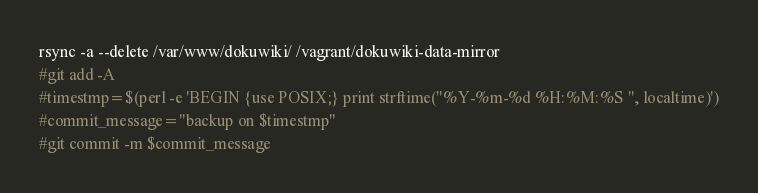Convert code to text. <code><loc_0><loc_0><loc_500><loc_500><_Bash_>rsync -a --delete /var/www/dokuwiki/ /vagrant/dokuwiki-data-mirror
#git add -A
#timestmp=$(perl -e 'BEGIN {use POSIX;} print strftime("%Y-%m-%d %H:%M:%S ", localtime)')
#commit_message="backup on $timestmp"
#git commit -m $commit_message</code> 